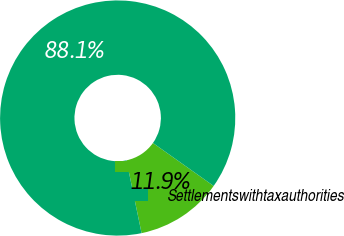Convert chart to OTSL. <chart><loc_0><loc_0><loc_500><loc_500><pie_chart><ecel><fcel>Settlementswithtaxauthorities<nl><fcel>11.94%<fcel>88.06%<nl></chart> 